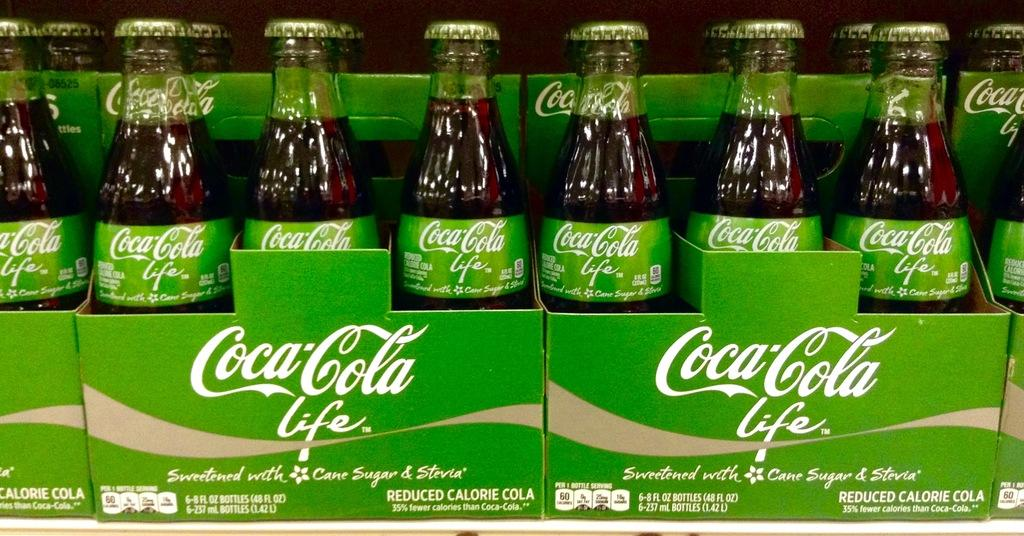<image>
Offer a succinct explanation of the picture presented. A row of six pack bottles of Coca Cola Life 